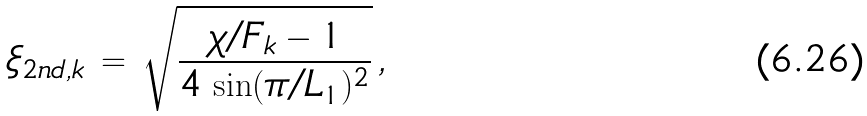<formula> <loc_0><loc_0><loc_500><loc_500>\xi _ { 2 n d , k } \, = \, \sqrt { \frac { \chi / F _ { k } - 1 } { 4 \, \sin ( \pi / L _ { 1 } ) ^ { 2 } } } \, ,</formula> 